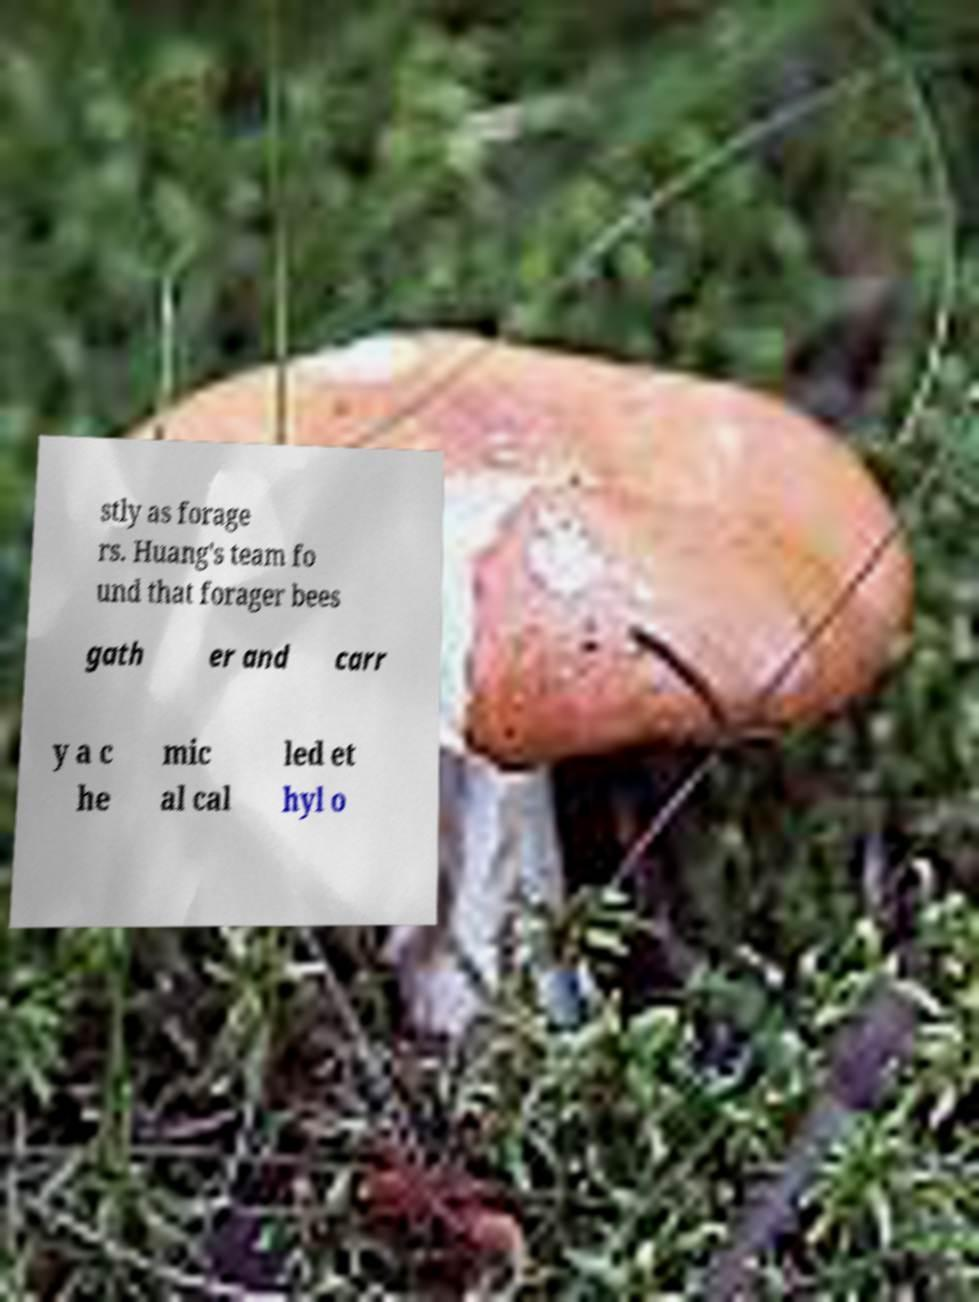What messages or text are displayed in this image? I need them in a readable, typed format. stly as forage rs. Huang's team fo und that forager bees gath er and carr y a c he mic al cal led et hyl o 